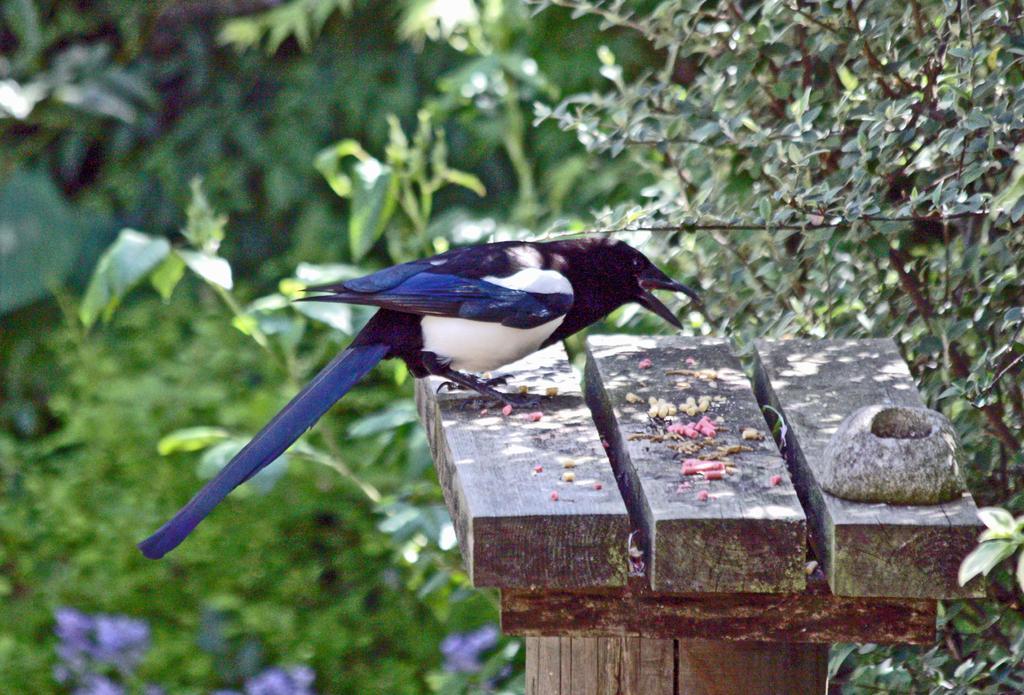Please provide a concise description of this image. In this image there is a bird on a wooden object. Background there are plants having leaves. Bottom of the image there are plants having flowers 